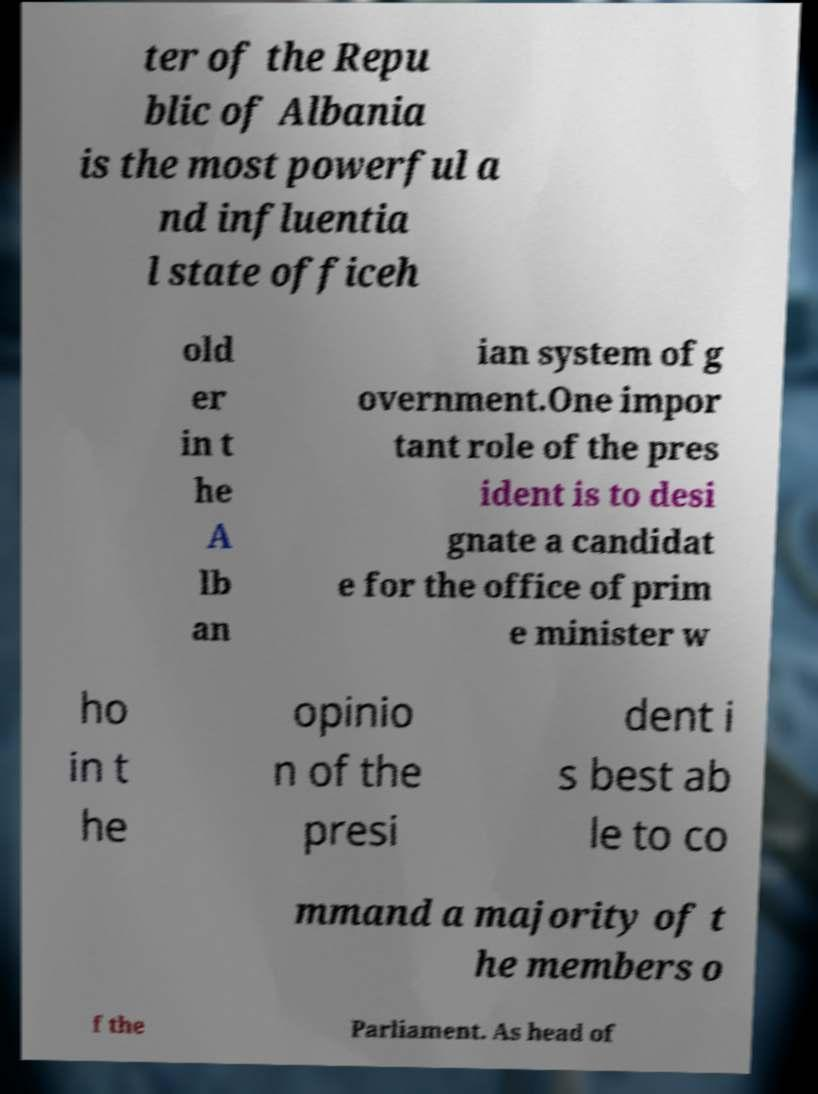Can you read and provide the text displayed in the image?This photo seems to have some interesting text. Can you extract and type it out for me? ter of the Repu blic of Albania is the most powerful a nd influentia l state officeh old er in t he A lb an ian system of g overnment.One impor tant role of the pres ident is to desi gnate a candidat e for the office of prim e minister w ho in t he opinio n of the presi dent i s best ab le to co mmand a majority of t he members o f the Parliament. As head of 